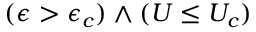Convert formula to latex. <formula><loc_0><loc_0><loc_500><loc_500>( \epsilon > \epsilon _ { c } ) \wedge ( U \leq U _ { c } )</formula> 